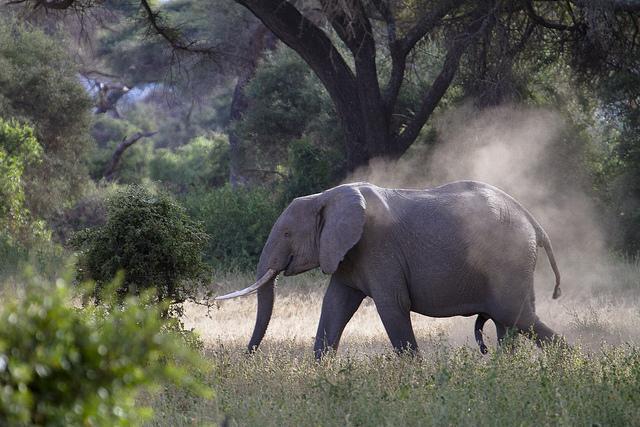How many tusks are visible?
Give a very brief answer. 1. 